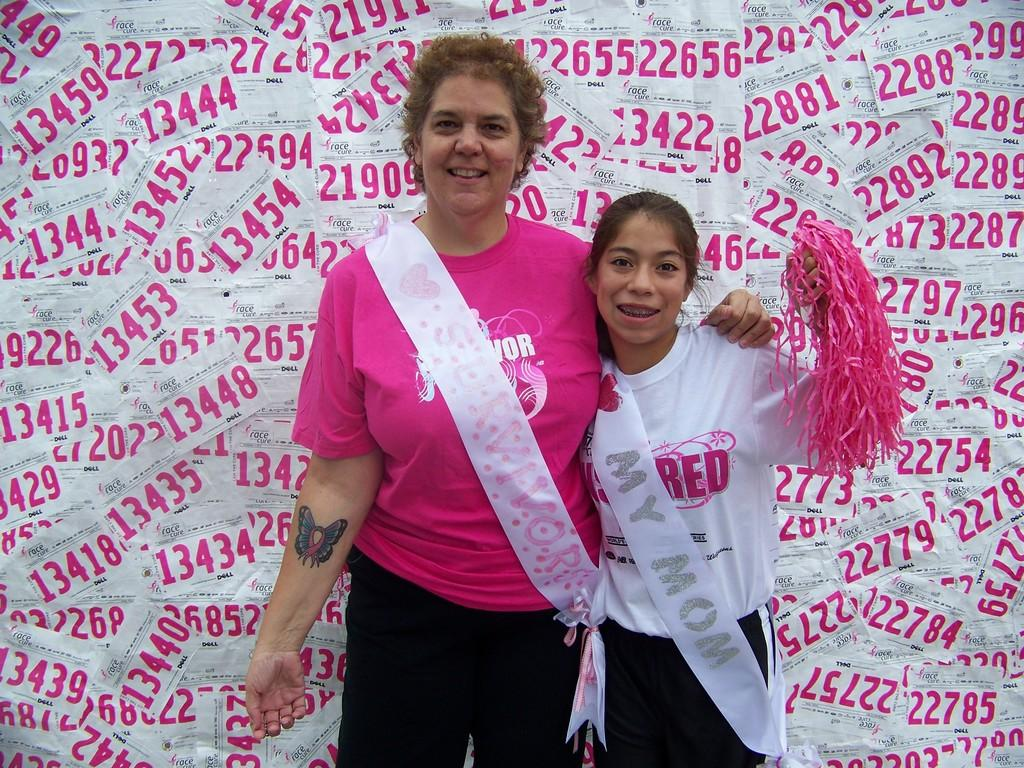How many people are in the image? There are two persons standing in the image. What are the persons wearing that is visible in the image? The persons are wearing sashes. What can be seen in the background of the image? There are posters in the background of the image. What type of muscle is being flexed by the person on the left in the image? There is no muscle being flexed in the image; the persons are wearing sashes. What is the value of the wristwatch worn by the person on the right in the image? There is no wristwatch visible in the image; the persons are wearing sashes. 